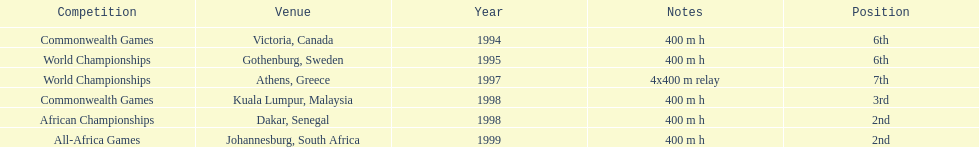In what year did ken harnden participate in more than one competition? 1998. I'm looking to parse the entire table for insights. Could you assist me with that? {'header': ['Competition', 'Venue', 'Year', 'Notes', 'Position'], 'rows': [['Commonwealth Games', 'Victoria, Canada', '1994', '400 m h', '6th'], ['World Championships', 'Gothenburg, Sweden', '1995', '400 m h', '6th'], ['World Championships', 'Athens, Greece', '1997', '4x400 m relay', '7th'], ['Commonwealth Games', 'Kuala Lumpur, Malaysia', '1998', '400 m h', '3rd'], ['African Championships', 'Dakar, Senegal', '1998', '400 m h', '2nd'], ['All-Africa Games', 'Johannesburg, South Africa', '1999', '400 m h', '2nd']]} 